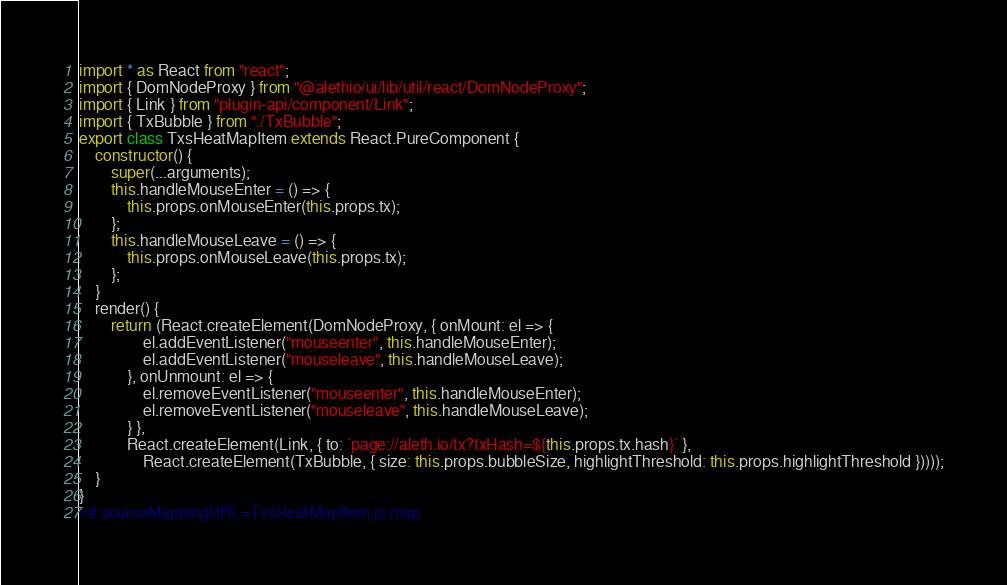<code> <loc_0><loc_0><loc_500><loc_500><_JavaScript_>import * as React from "react";
import { DomNodeProxy } from "@alethio/ui/lib/util/react/DomNodeProxy";
import { Link } from "plugin-api/component/Link";
import { TxBubble } from "./TxBubble";
export class TxsHeatMapItem extends React.PureComponent {
    constructor() {
        super(...arguments);
        this.handleMouseEnter = () => {
            this.props.onMouseEnter(this.props.tx);
        };
        this.handleMouseLeave = () => {
            this.props.onMouseLeave(this.props.tx);
        };
    }
    render() {
        return (React.createElement(DomNodeProxy, { onMount: el => {
                el.addEventListener("mouseenter", this.handleMouseEnter);
                el.addEventListener("mouseleave", this.handleMouseLeave);
            }, onUnmount: el => {
                el.removeEventListener("mouseenter", this.handleMouseEnter);
                el.removeEventListener("mouseleave", this.handleMouseLeave);
            } },
            React.createElement(Link, { to: `page://aleth.io/tx?txHash=${this.props.tx.hash}` },
                React.createElement(TxBubble, { size: this.props.bubbleSize, highlightThreshold: this.props.highlightThreshold }))));
    }
}
//# sourceMappingURL=TxsHeatMapItem.js.map</code> 